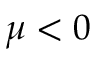<formula> <loc_0><loc_0><loc_500><loc_500>\mu < 0</formula> 